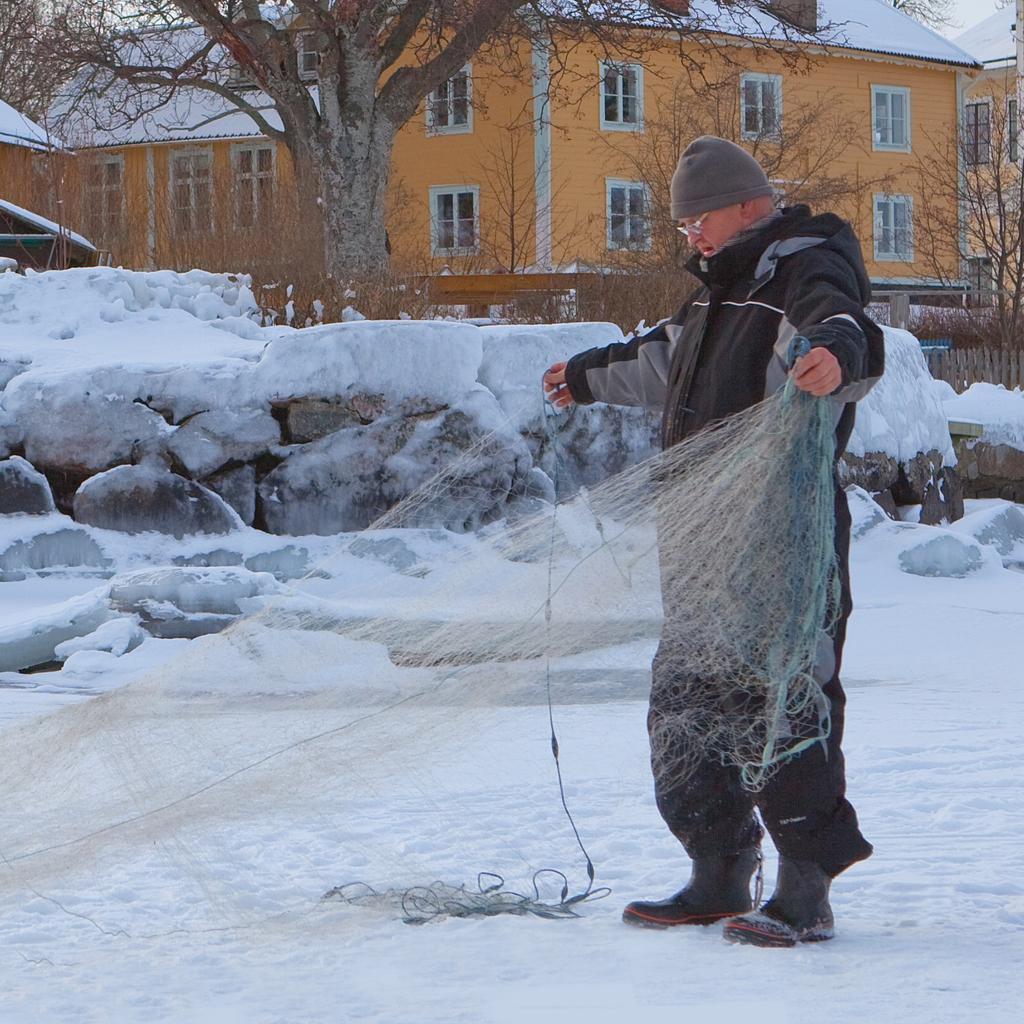Can you describe this image briefly? At the bottom of the image there is snow. In the middle of the image a person is standing and holding a net. At the top of the image there are some stones and trees. Behind them there are some buildings. 